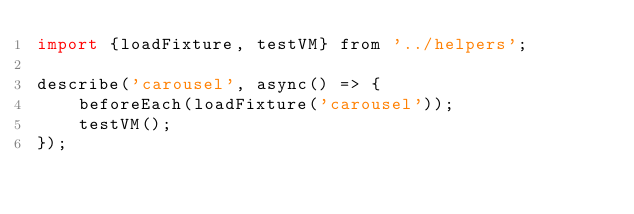Convert code to text. <code><loc_0><loc_0><loc_500><loc_500><_JavaScript_>import {loadFixture, testVM} from '../helpers';

describe('carousel', async() => {
    beforeEach(loadFixture('carousel'));
    testVM();
});</code> 